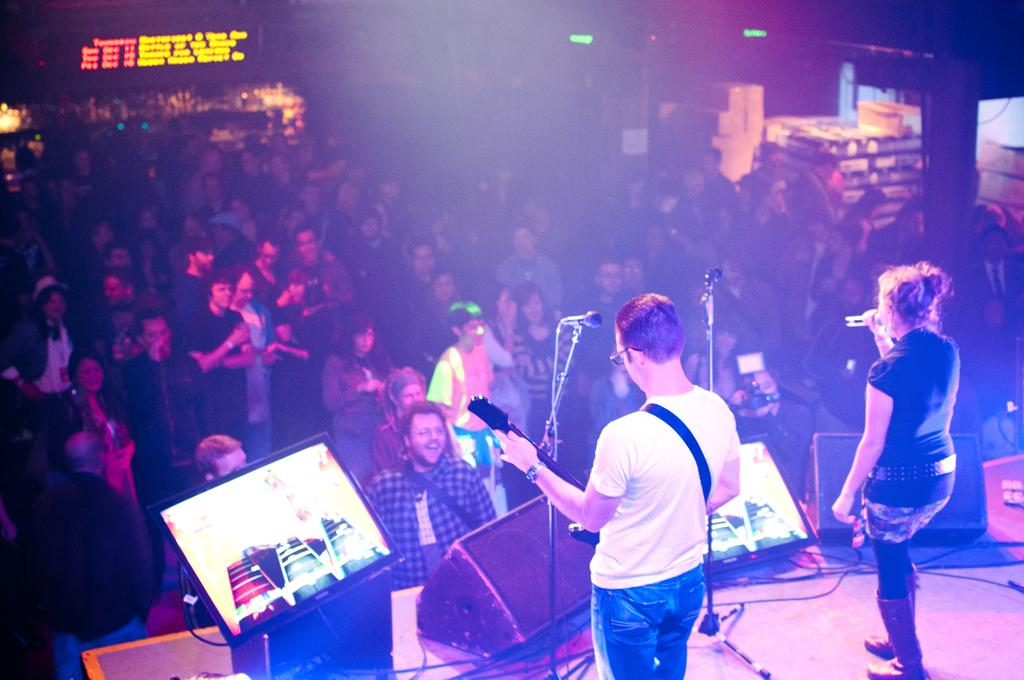What is happening in the image? There are people standing in the image, with a man and a woman standing on a stage. What is the man holding in the image? The man is holding a guitar. What is the woman doing in the image? The woman is singing into a microphone. What type of knee surgery did the man undergo before performing in the image? There is no information about any knee surgery in the image or the provided facts. 